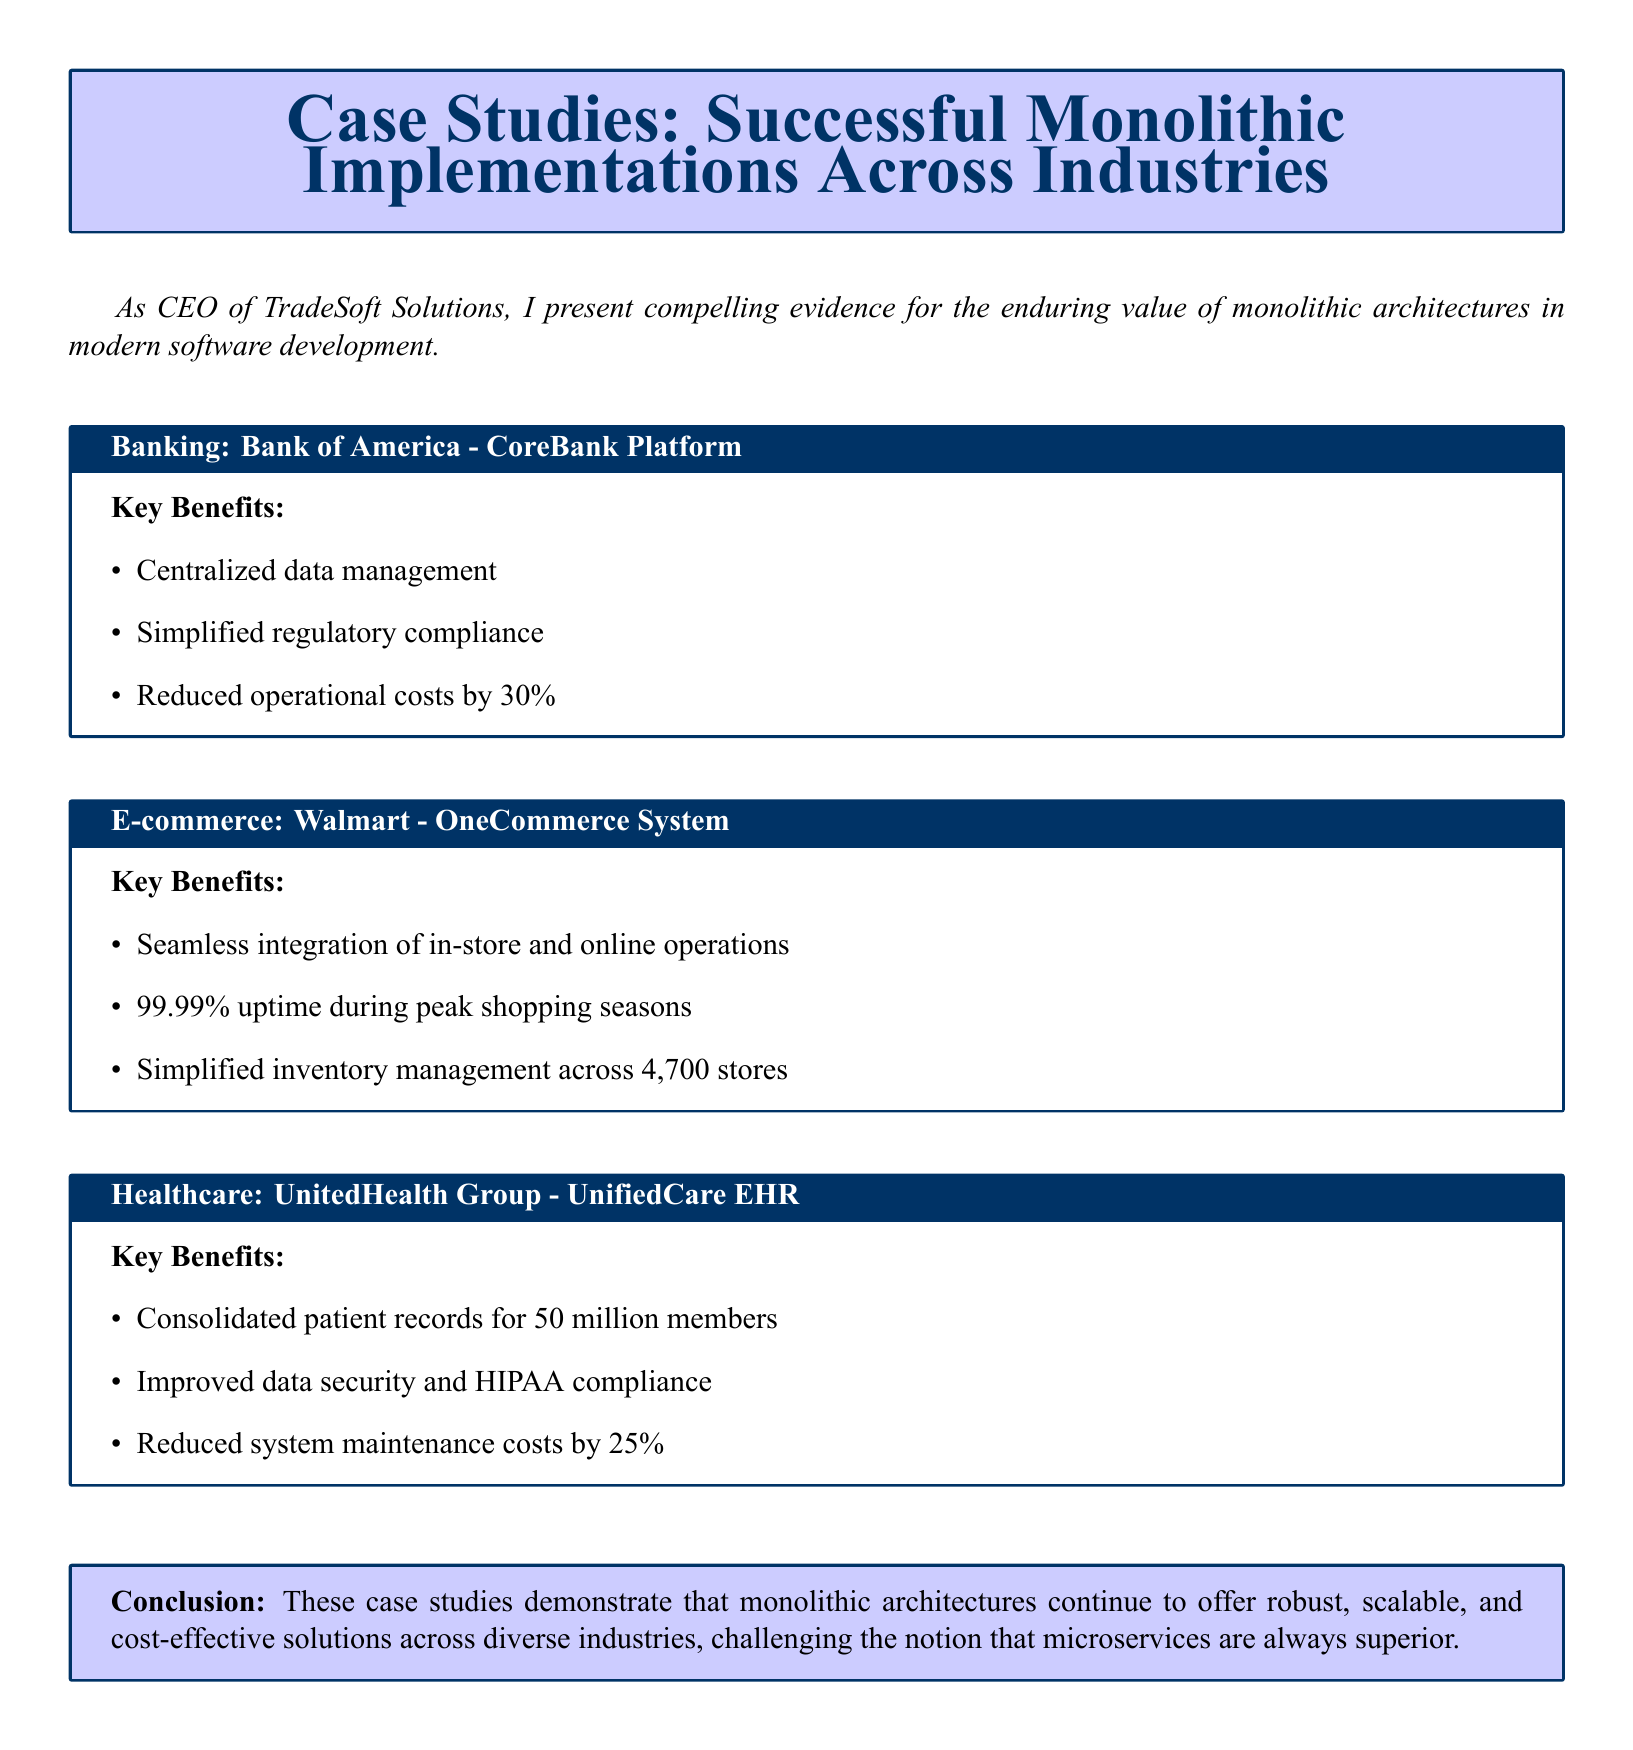What is the name of the banking case study? The document mentions the "Bank of America - CoreBank Platform" as the banking case study.
Answer: Bank of America - CoreBank Platform What percentage reduction in operational costs did the Bank of America achieve? The document states that Bank of America reduced operational costs by 30%.
Answer: 30% What is the uptime percentage noted for Walmart's OneCommerce System? The document highlights that Walmart achieved 99.99% uptime during peak shopping seasons with the OneCommerce System.
Answer: 99.99% How many members' records were consolidated in the UnitedHealth Group's UnifiedCare EHR? The document specifies that UnitedHealth Group consolidated patient records for 50 million members.
Answer: 50 million What is the main conclusion drawn in the catalog? The document concludes that monolithic architectures continue to offer robust, scalable, and cost-effective solutions across diverse industries.
Answer: Robust, scalable, and cost-effective solutions What are the key benefits mentioned for the UnitedHealth Group case study? The document lists improved data security and HIPAA compliance as key benefits along with other specifics.
Answer: Improved data security and HIPAA compliance Which system is mentioned for simplifying inventory management across stores? The document refers to Walmart's OneCommerce System for simplifying inventory management across stores.
Answer: OneCommerce System What percentage reduction in system maintenance costs did UnitedHealth Group achieve? The reduction in system maintenance costs by UnitedHealth Group is specified as 25% in the document.
Answer: 25% 